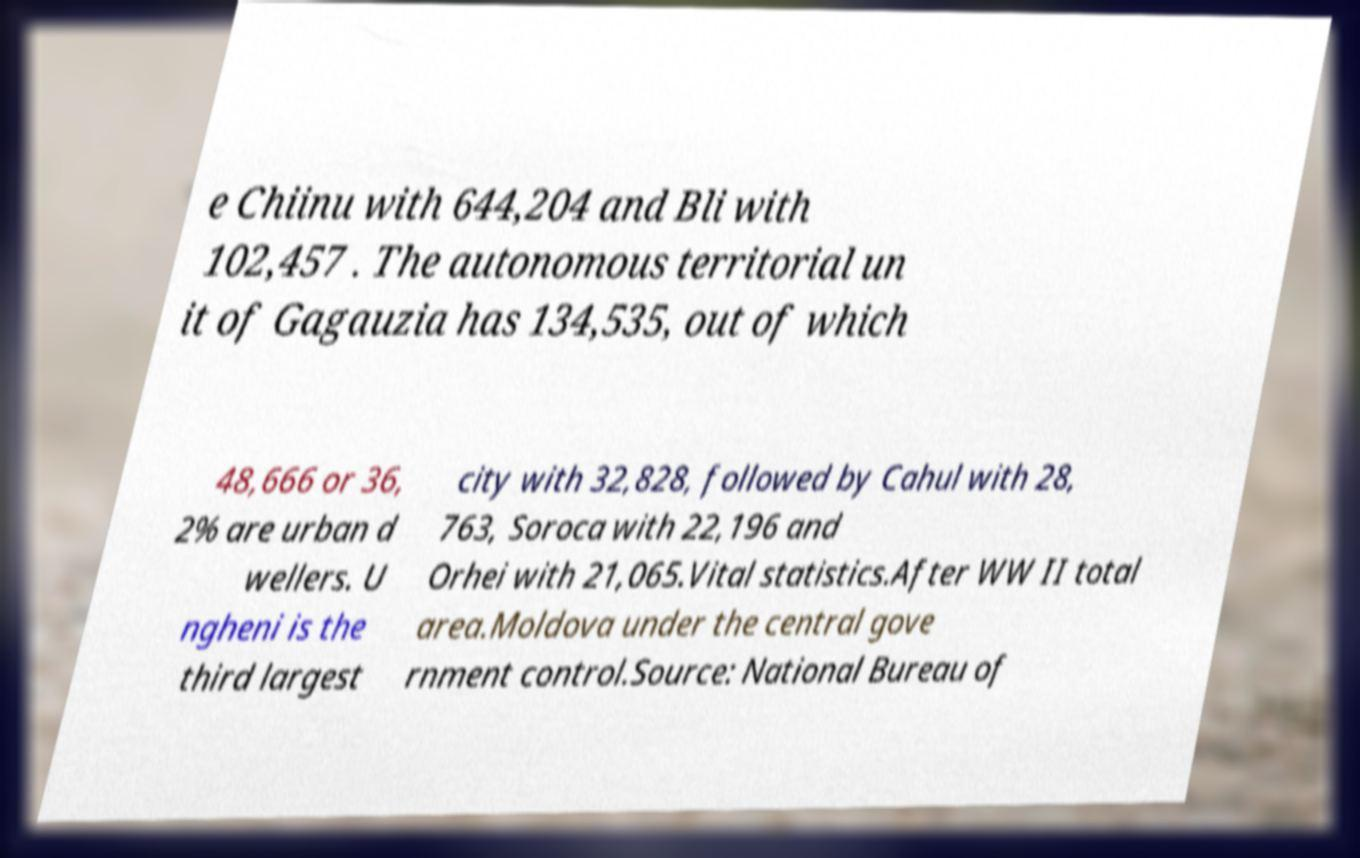What messages or text are displayed in this image? I need them in a readable, typed format. e Chiinu with 644,204 and Bli with 102,457 . The autonomous territorial un it of Gagauzia has 134,535, out of which 48,666 or 36, 2% are urban d wellers. U ngheni is the third largest city with 32,828, followed by Cahul with 28, 763, Soroca with 22,196 and Orhei with 21,065.Vital statistics.After WW II total area.Moldova under the central gove rnment control.Source: National Bureau of 